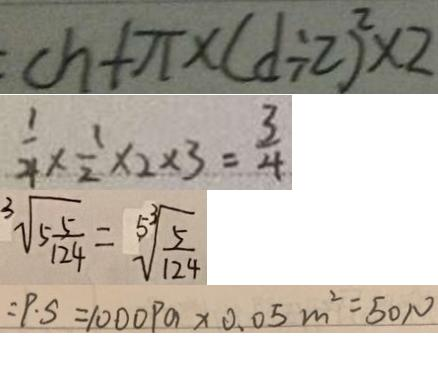Convert formula to latex. <formula><loc_0><loc_0><loc_500><loc_500>c h + \pi \times ( d \div 2 ) ^ { 2 } \times 2 
 \frac { 1 } { 4 } \times \frac { 1 } { 2 } \times 2 \times 3 = \frac { 3 } { 4 } 
 \sqrt [ 3 ] { 5 \frac { 5 } { 1 2 4 } } = \sqrt [ 5 ^ { 3 } ] { \frac { 5 } { 1 2 4 } } 
 : P \cdot S = 1 0 0 0 P a \times 0 . 0 5 m ^ { 2 } = 5 0 N</formula> 